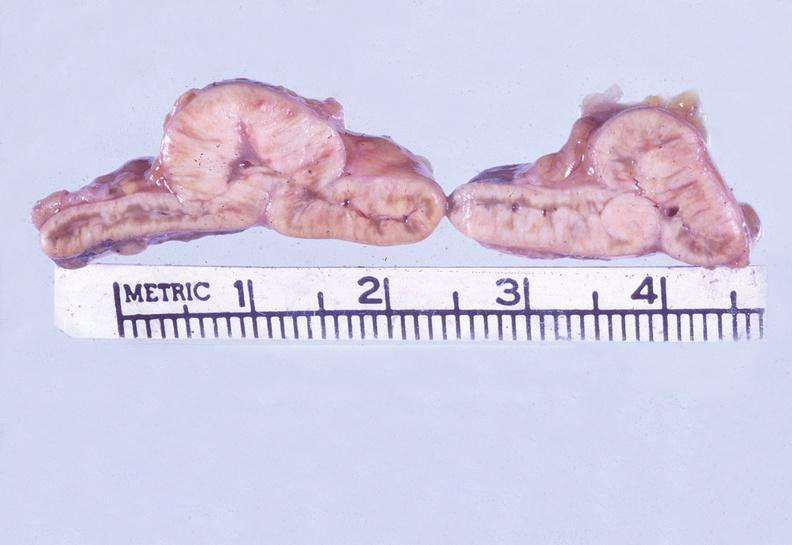what is present?
Answer the question using a single word or phrase. Endocrine 